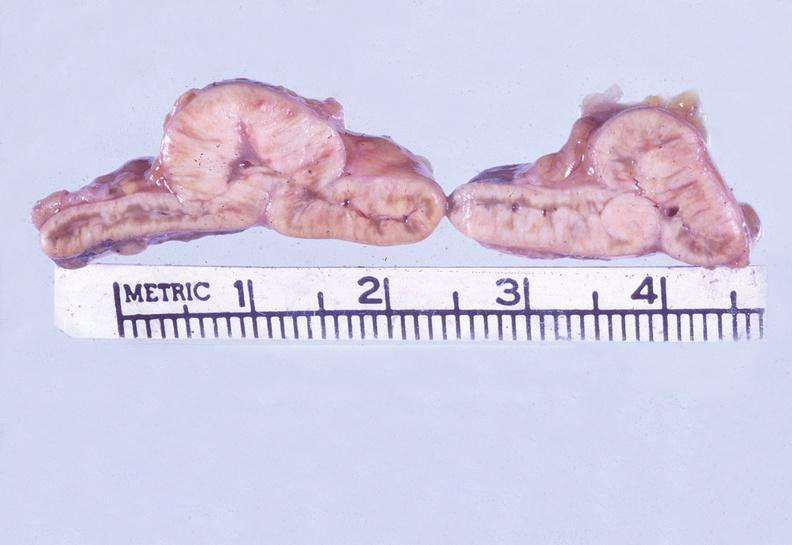what is present?
Answer the question using a single word or phrase. Endocrine 